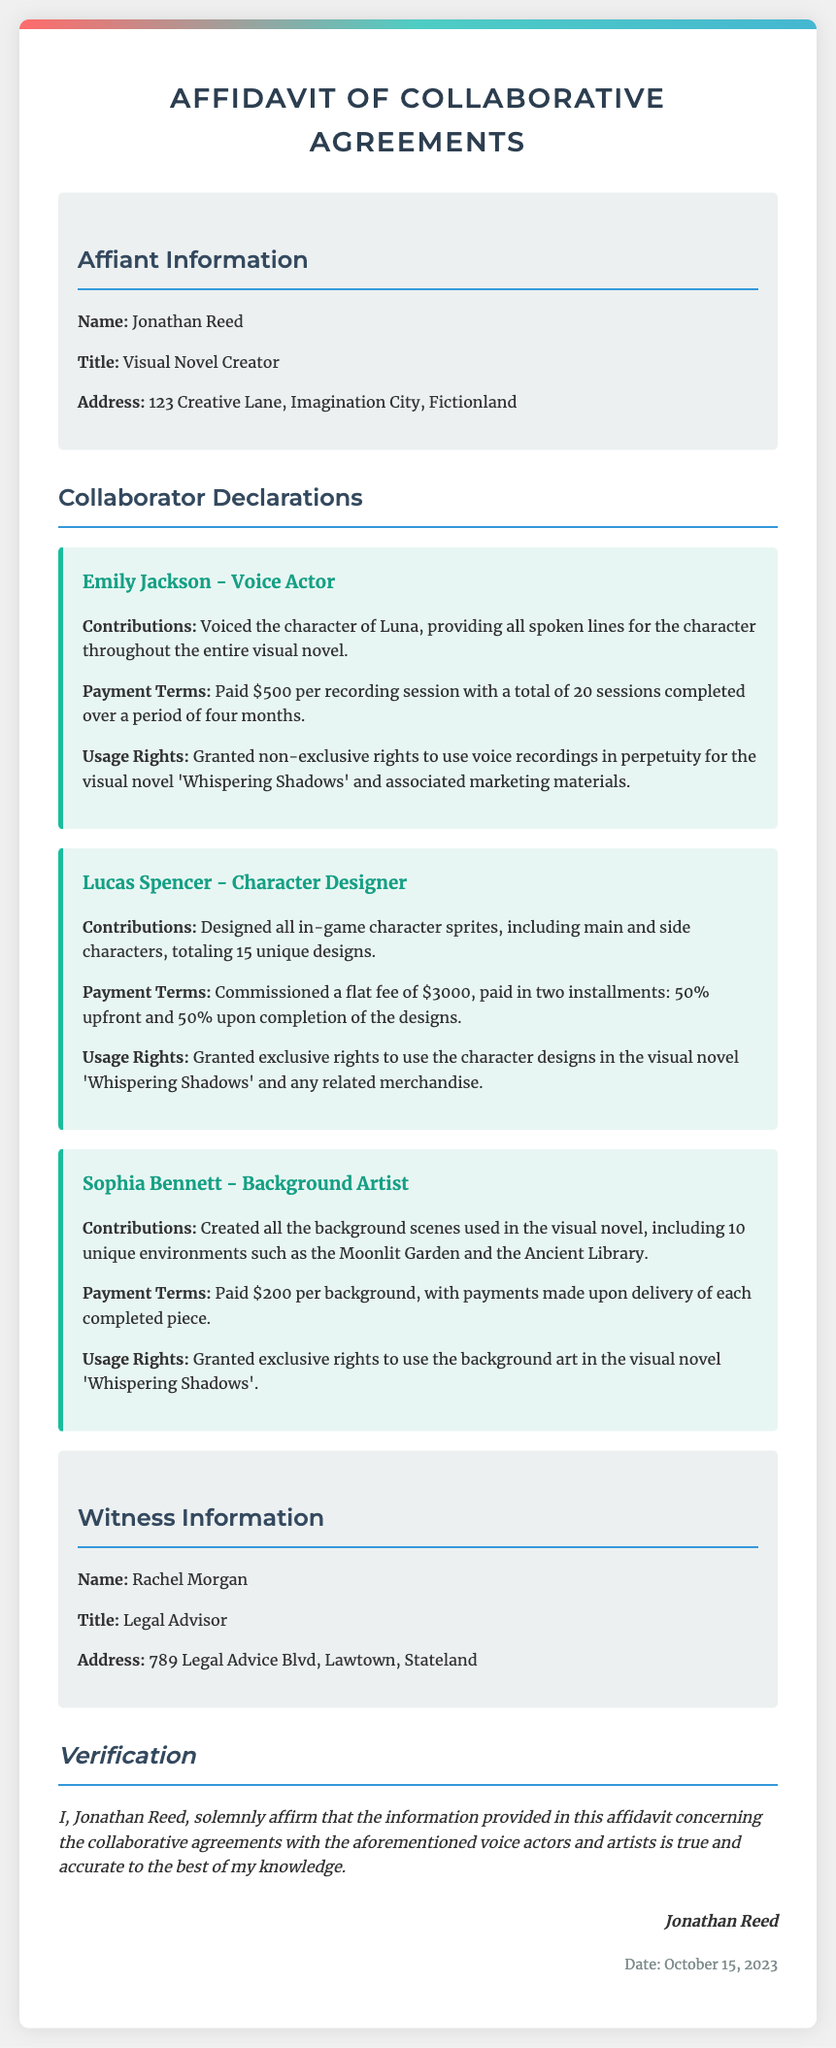what is the name of the affiant? The name of the affiant is mentioned in the document as Jonathan Reed.
Answer: Jonathan Reed what is the total number of voice recording sessions completed by Emily Jackson? The document states that Emily Jackson completed a total of 20 sessions for voice recording.
Answer: 20 what is the payment amount for each session Emily Jackson was paid? The payment terms for Emily Jackson specify that she was paid $500 per recording session.
Answer: $500 who is the character designer mentioned in the affidavit? The affidavit names Lucas Spencer as the character designer contributing to the project.
Answer: Lucas Spencer how much was the flat fee paid to Lucas Spencer for his work? The document indicates that Lucas Spencer was paid a total flat fee of $3000 for his designs.
Answer: $3000 what rights were granted to Sophia Bennett for her background art? The affidavit mentions that exclusive rights were granted to use the background art created by Sophia Bennett in the visual novel 'Whispering Shadows'.
Answer: Exclusive rights what is the date when the affidavit was signed? The document indicates that the affidavit was dated October 15, 2023.
Answer: October 15, 2023 who is listed as the witness to the affidavit? The witness information section names Rachel Morgan as the witness.
Answer: Rachel Morgan what title does Jonathan Reed hold? The document specifies that Jonathan Reed's title is Visual Novel Creator.
Answer: Visual Novel Creator 